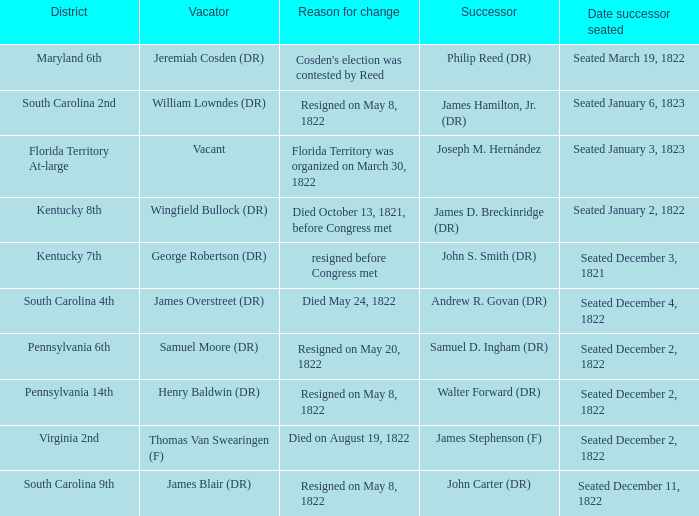What is the reason for change when maryland 6th is the district?  Cosden's election was contested by Reed. 